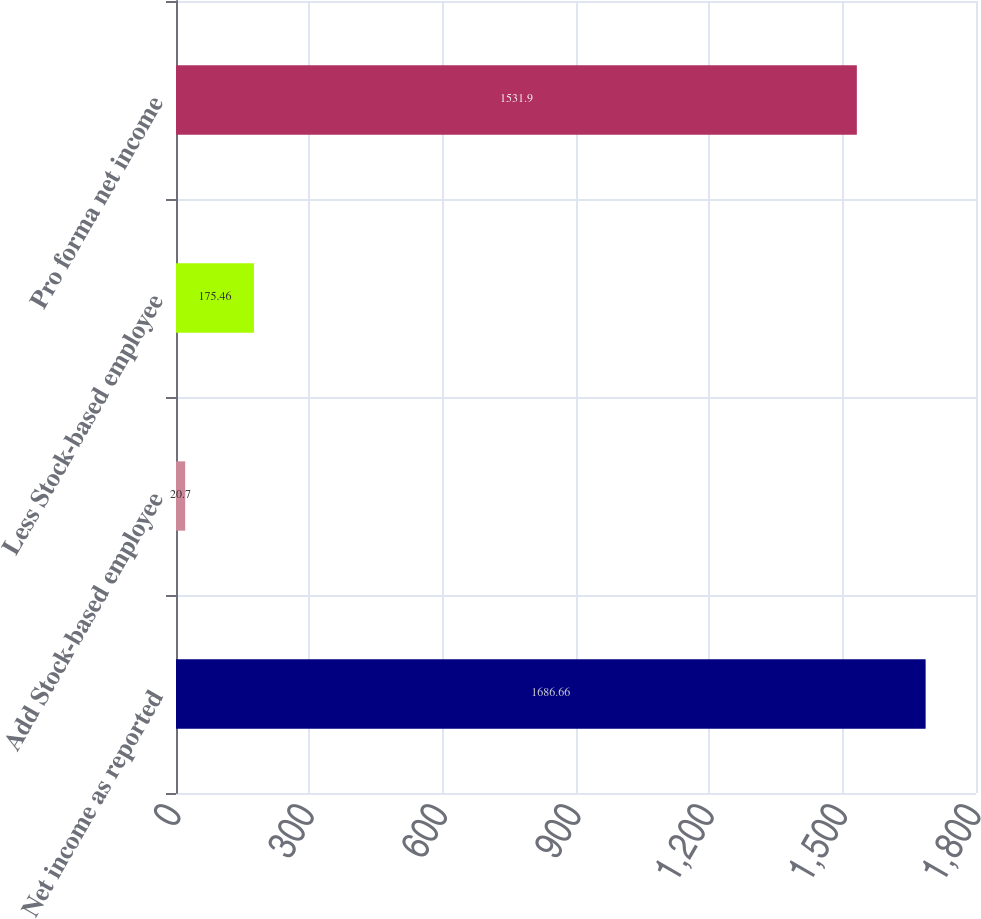Convert chart to OTSL. <chart><loc_0><loc_0><loc_500><loc_500><bar_chart><fcel>Net income as reported<fcel>Add Stock-based employee<fcel>Less Stock-based employee<fcel>Pro forma net income<nl><fcel>1686.66<fcel>20.7<fcel>175.46<fcel>1531.9<nl></chart> 